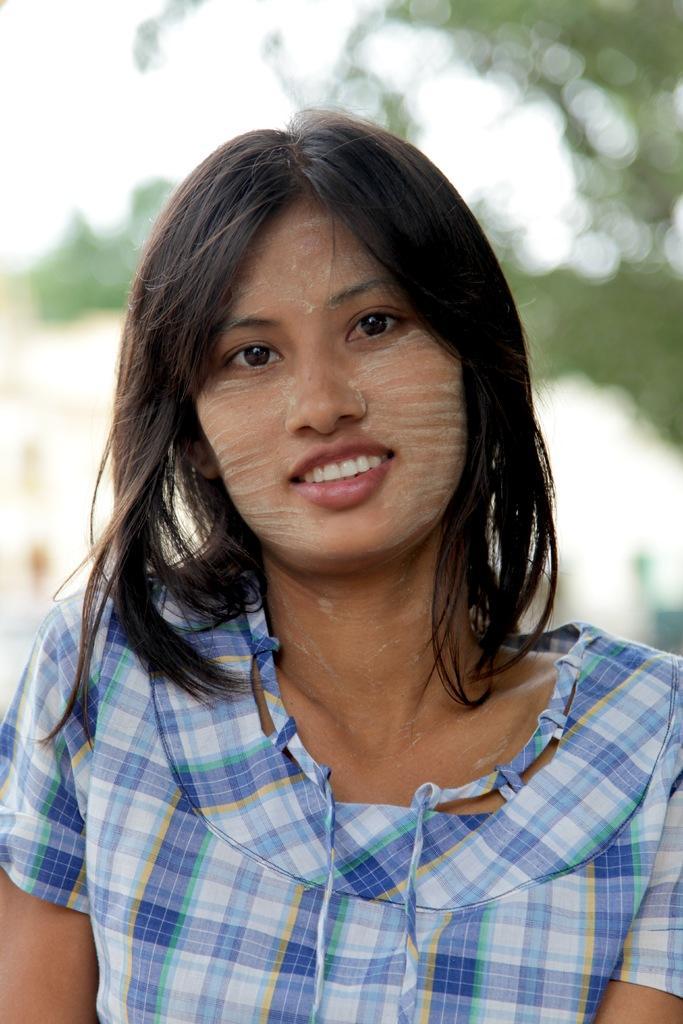How would you summarize this image in a sentence or two? In this image I can see the person with the dress and I can see the blurred background. 